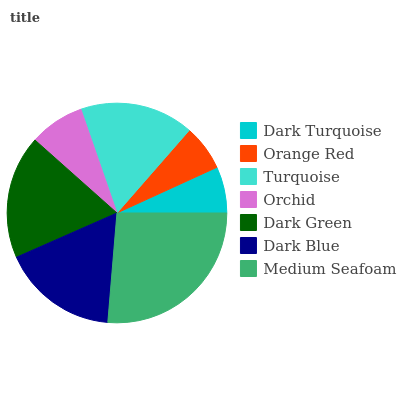Is Orange Red the minimum?
Answer yes or no. Yes. Is Medium Seafoam the maximum?
Answer yes or no. Yes. Is Turquoise the minimum?
Answer yes or no. No. Is Turquoise the maximum?
Answer yes or no. No. Is Turquoise greater than Orange Red?
Answer yes or no. Yes. Is Orange Red less than Turquoise?
Answer yes or no. Yes. Is Orange Red greater than Turquoise?
Answer yes or no. No. Is Turquoise less than Orange Red?
Answer yes or no. No. Is Turquoise the high median?
Answer yes or no. Yes. Is Turquoise the low median?
Answer yes or no. Yes. Is Orange Red the high median?
Answer yes or no. No. Is Orchid the low median?
Answer yes or no. No. 